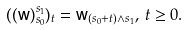<formula> <loc_0><loc_0><loc_500><loc_500>( ( { \mathsf w } ) _ { s _ { 0 } } ^ { s _ { 1 } } ) _ { t } = { \mathsf w } _ { ( s _ { 0 } + t ) \wedge s _ { 1 } } , \, t \geq 0 .</formula> 